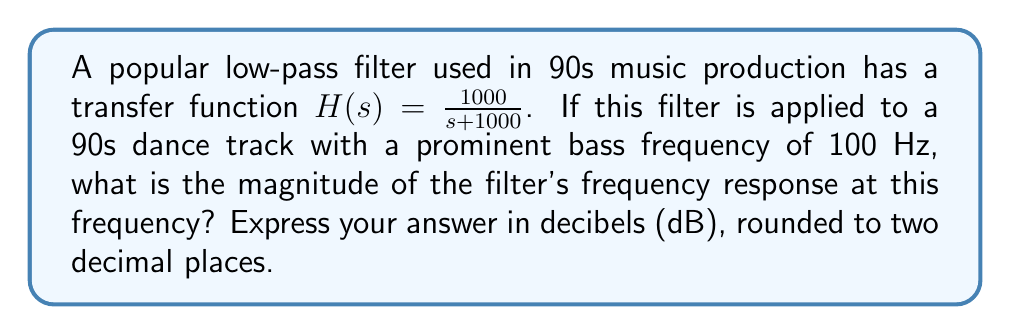Solve this math problem. To solve this problem, we need to follow these steps:

1) The transfer function is given as $H(s) = \frac{1000}{s + 1000}$

2) To find the frequency response, we replace s with $j\omega$:
   $H(j\omega) = \frac{1000}{j\omega + 1000}$

3) The frequency we're interested in is 100 Hz, so $\omega = 2\pi f = 2\pi(100) = 200\pi$

4) Let's substitute this into our frequency response:
   $H(j200\pi) = \frac{1000}{j200\pi + 1000}$

5) To find the magnitude, we use:
   $|H(j\omega)| = \frac{|1000|}{\sqrt{(1000)^2 + (200\pi)^2}}$

6) Calculating:
   $|H(j200\pi)| = \frac{1000}{\sqrt{1000000 + 157914.1}} = \frac{1000}{\sqrt{1157914.1}} = 0.9285$

7) To convert to decibels, we use the formula:
   $\text{Magnitude in dB} = 20 \log_{10}(|H(j\omega)|)$

8) Substituting our magnitude:
   $20 \log_{10}(0.9285) = -0.6426$ dB

9) Rounding to two decimal places: -0.64 dB
Answer: -0.64 dB 